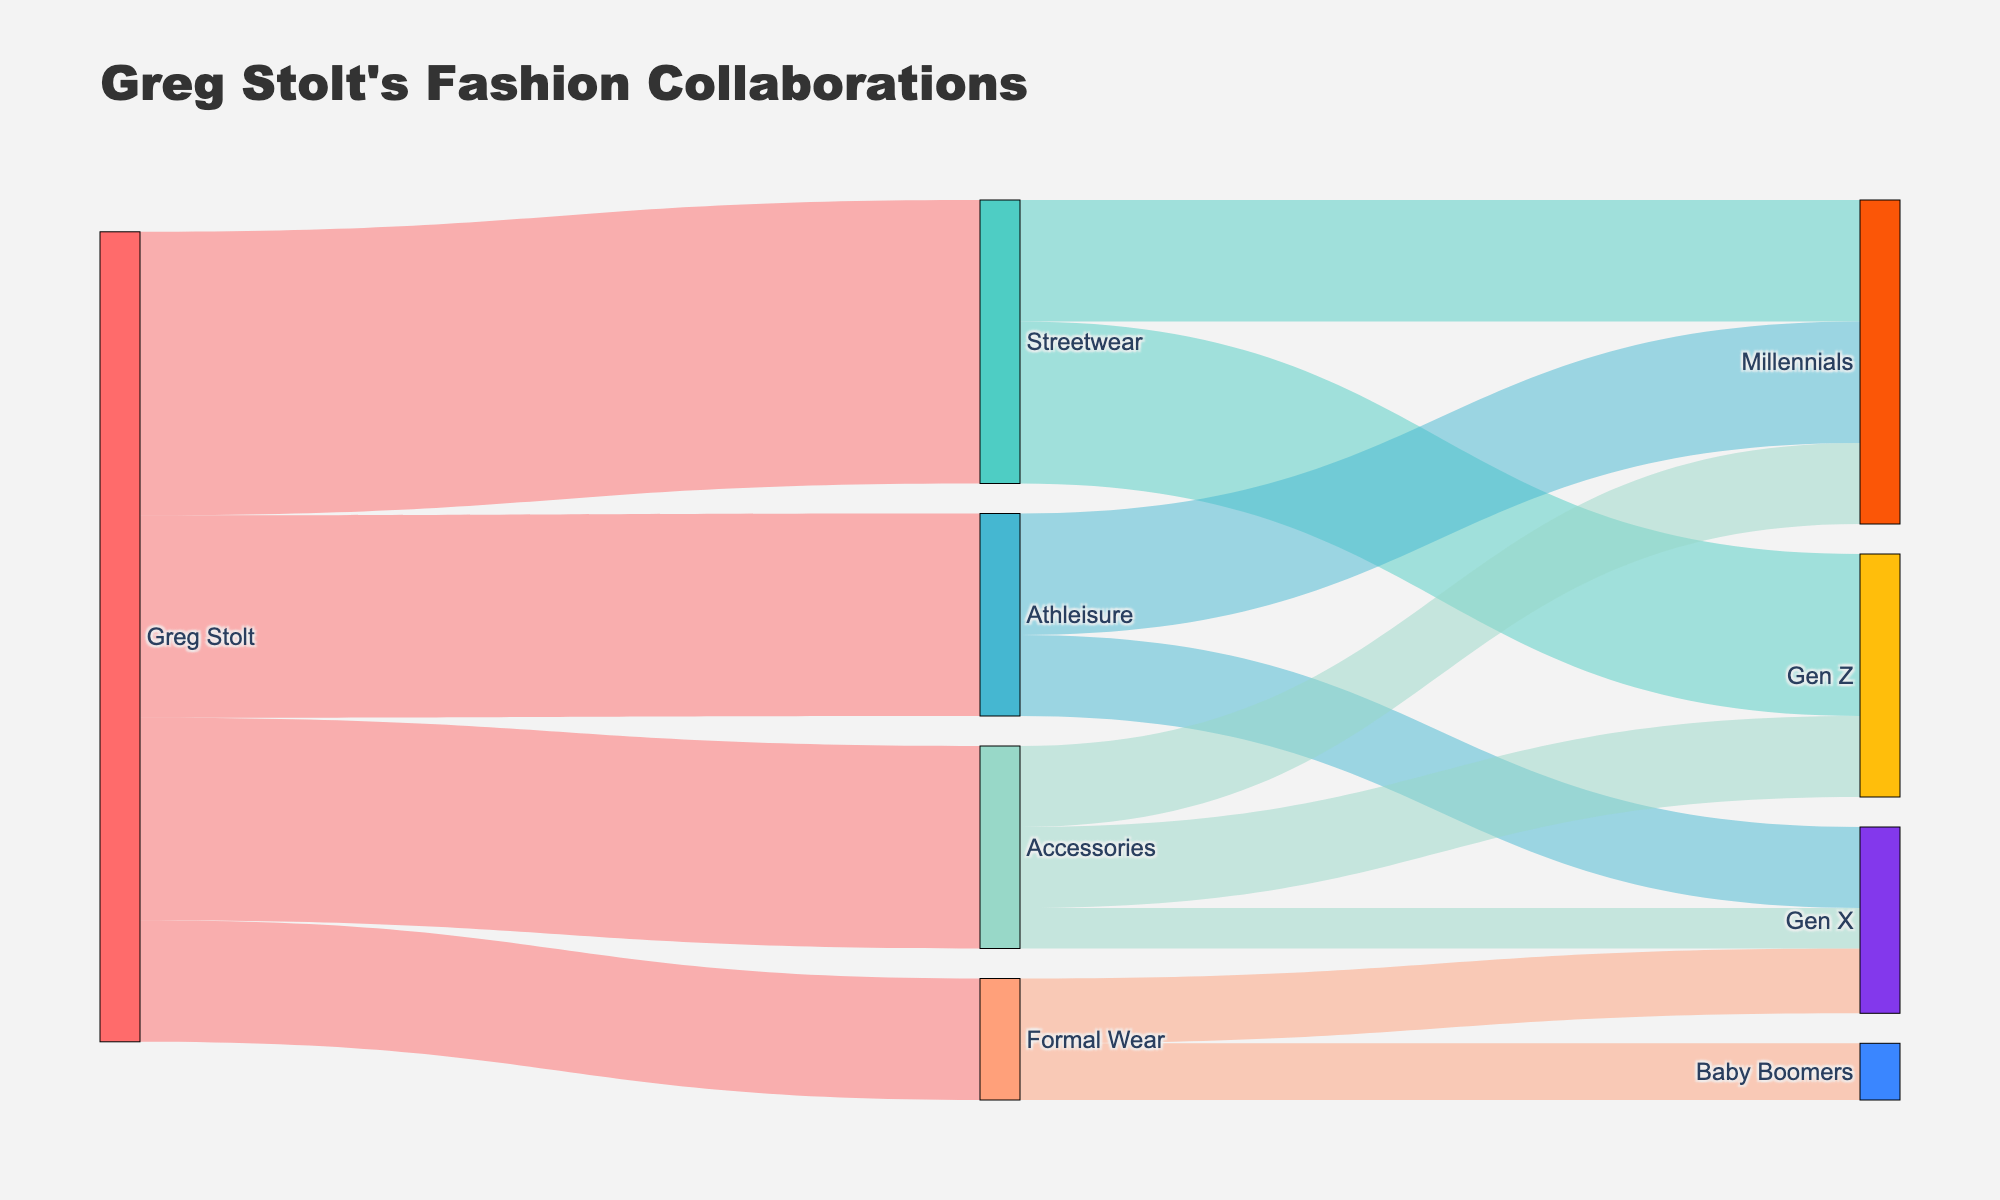what's the main title of the figure? The main title of the Sankey Diagram is typically displayed at the top of the figure in larger font. Here, it is clearly stated in the layout configuration part of the code.
Answer: Greg Stolt's Fashion Collaborations What is the color representing 'Greg Stolt'? The color representing 'Greg Stolt' can be identified by looking at the diagram and finding the corresponding node labeled 'Greg Stolt'. According to the provided color dictionary, 'Greg Stolt' is associated with a red-like color.
Answer: #FF6B6B Which style categories has Greg Stolt collaborated the most in? By looking at the width of the links or the values connecting 'Greg Stolt' to the style categories, the category with the widest link or highest value indicates the most collaborations. In this case, ‘Streetwear’ has the largest value of 35.
Answer: Streetwear What is the total number of collaborations Greg Stolt has done in Athleisure and Accessories combined? Sum the number of collaborations for 'Athleisure' and 'Accessories'. According to the data, Athleisure has 25 and Accessories have 25, so 25 + 25 = 50.
Answer: 50 Which demographic has the highest number of collaborations in Streetwear? From the diagram, look at the demographics connected to 'Streetwear' and identify which has the largest value. 'Gen Z' has the highest value of 20 collaborations in Streetwear.
Answer: Gen Z What is the combined total number of collaborations in Gen X across all style categories? Sum the collaborations in Gen X across all relevant links. According to the data: Athleisure (10), Formal Wear (8), Accessories (5). Summing these values: 10 + 8 + 5 = 23.
Answer: 23 Compare the collaborations of 'Formal Wear' between 'Gen X' and 'Baby Boomers'. Which demographic has more? By looking at the link widths or values connecting 'Formal Wear' to each demographic, Gen X has 8 and Baby Boomers have 7. Gen X has more collaborations than Baby Boomers in 'Formal Wear'.
Answer: Gen X What percentage of Greg Stolt's collaborations are in Formal Wear? Divide the number of collaborations in Formal Wear by the total number of collaborations and multiply by 100 to get the percentage. Formal Wear has 15 collaborations out of a total of 100 (35 + 25 + 15 + 25). So, (15/100) * 100 = 15%.
Answer: 15% How does the number of collaborations in Accessories compare to those in Streetwear? Subtract the number of collaborations in Accessories from those in Streetwear. Accessories have 25 collaborations, and Streetwear has 35. The difference is 35 - 25 = 10.
Answer: 10 What is the overall trend of Greg Stolt's fashion collaborations among different generations? Examine the Sankey Diagram and sum the values connecting each generation across all styles to identify the overall distribution. Gen Z: 30 (20+10), Millennials: 40 (15+15+10), Gen X: 23 (10+8+5), Baby Boomers: 7. Millennials have the highest overall collaborations, followed by Gen Z, Gen X, and Baby Boomers.
Answer: Millennials have the highest, followed by Gen Z, Gen X, and Baby Boomers 